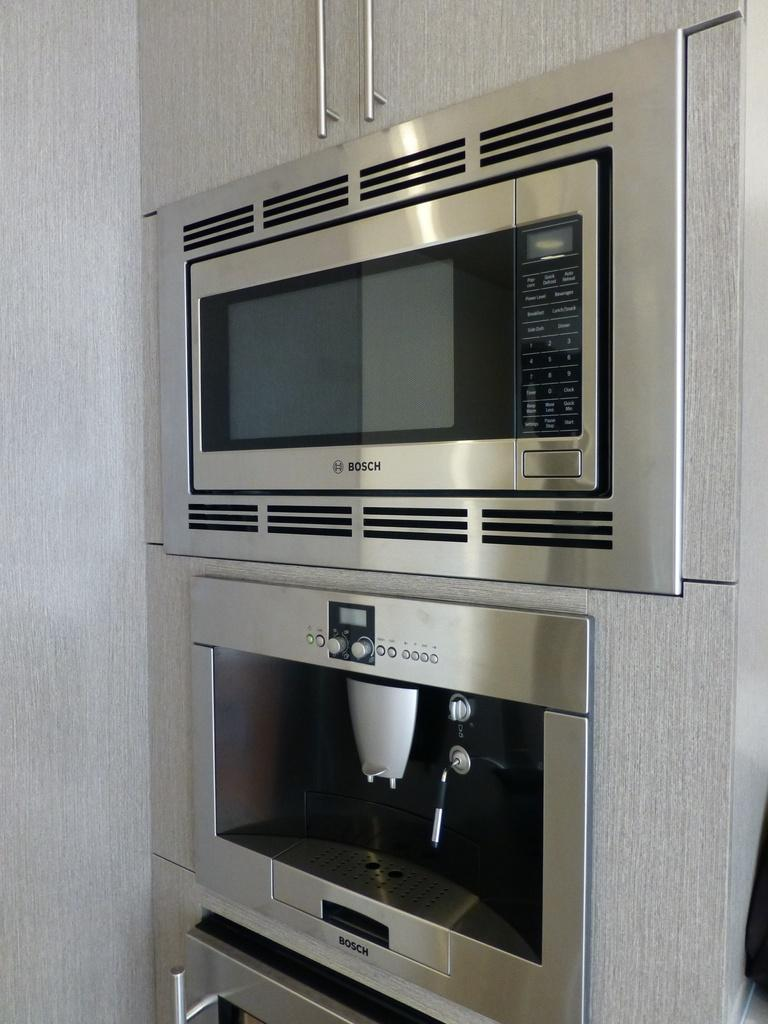Provide a one-sentence caption for the provided image. The very top appliance is a bosch microwave. 